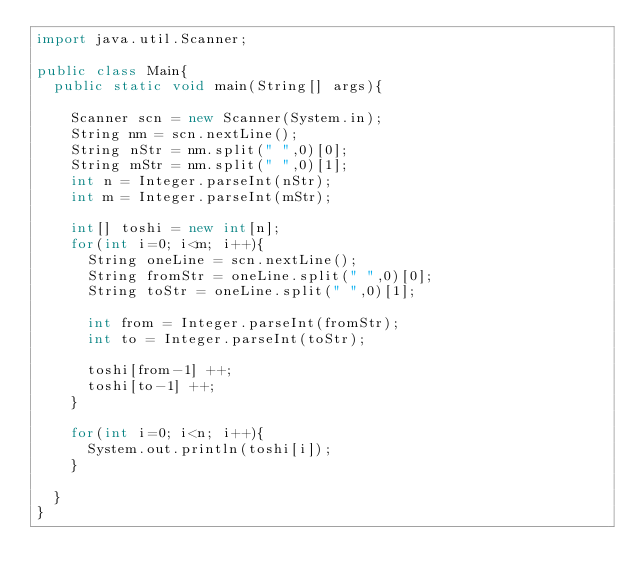Convert code to text. <code><loc_0><loc_0><loc_500><loc_500><_Java_>import java.util.Scanner;

public class Main{
  public static void main(String[] args){

    Scanner scn = new Scanner(System.in);
    String nm = scn.nextLine();
    String nStr = nm.split(" ",0)[0];
    String mStr = nm.split(" ",0)[1];
    int n = Integer.parseInt(nStr);
    int m = Integer.parseInt(mStr);

    int[] toshi = new int[n];
    for(int i=0; i<m; i++){
      String oneLine = scn.nextLine();
      String fromStr = oneLine.split(" ",0)[0];
      String toStr = oneLine.split(" ",0)[1];

      int from = Integer.parseInt(fromStr);
      int to = Integer.parseInt(toStr);

      toshi[from-1] ++;
      toshi[to-1] ++;
    }

    for(int i=0; i<n; i++){
      System.out.println(toshi[i]);
    }

  }
}</code> 